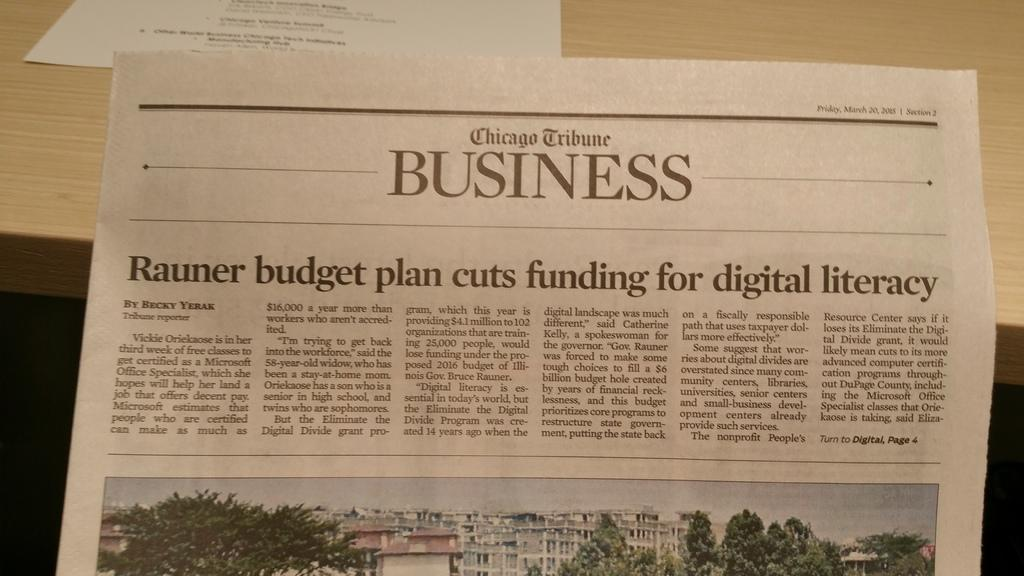<image>
Share a concise interpretation of the image provided. The Business section of the Chicago Tribune has an article about budget plan cuts. 